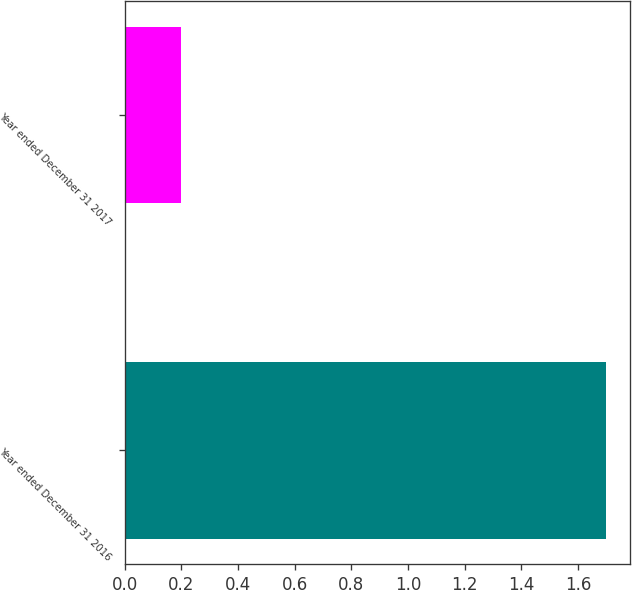Convert chart to OTSL. <chart><loc_0><loc_0><loc_500><loc_500><bar_chart><fcel>Year ended December 31 2016<fcel>Year ended December 31 2017<nl><fcel>1.7<fcel>0.2<nl></chart> 